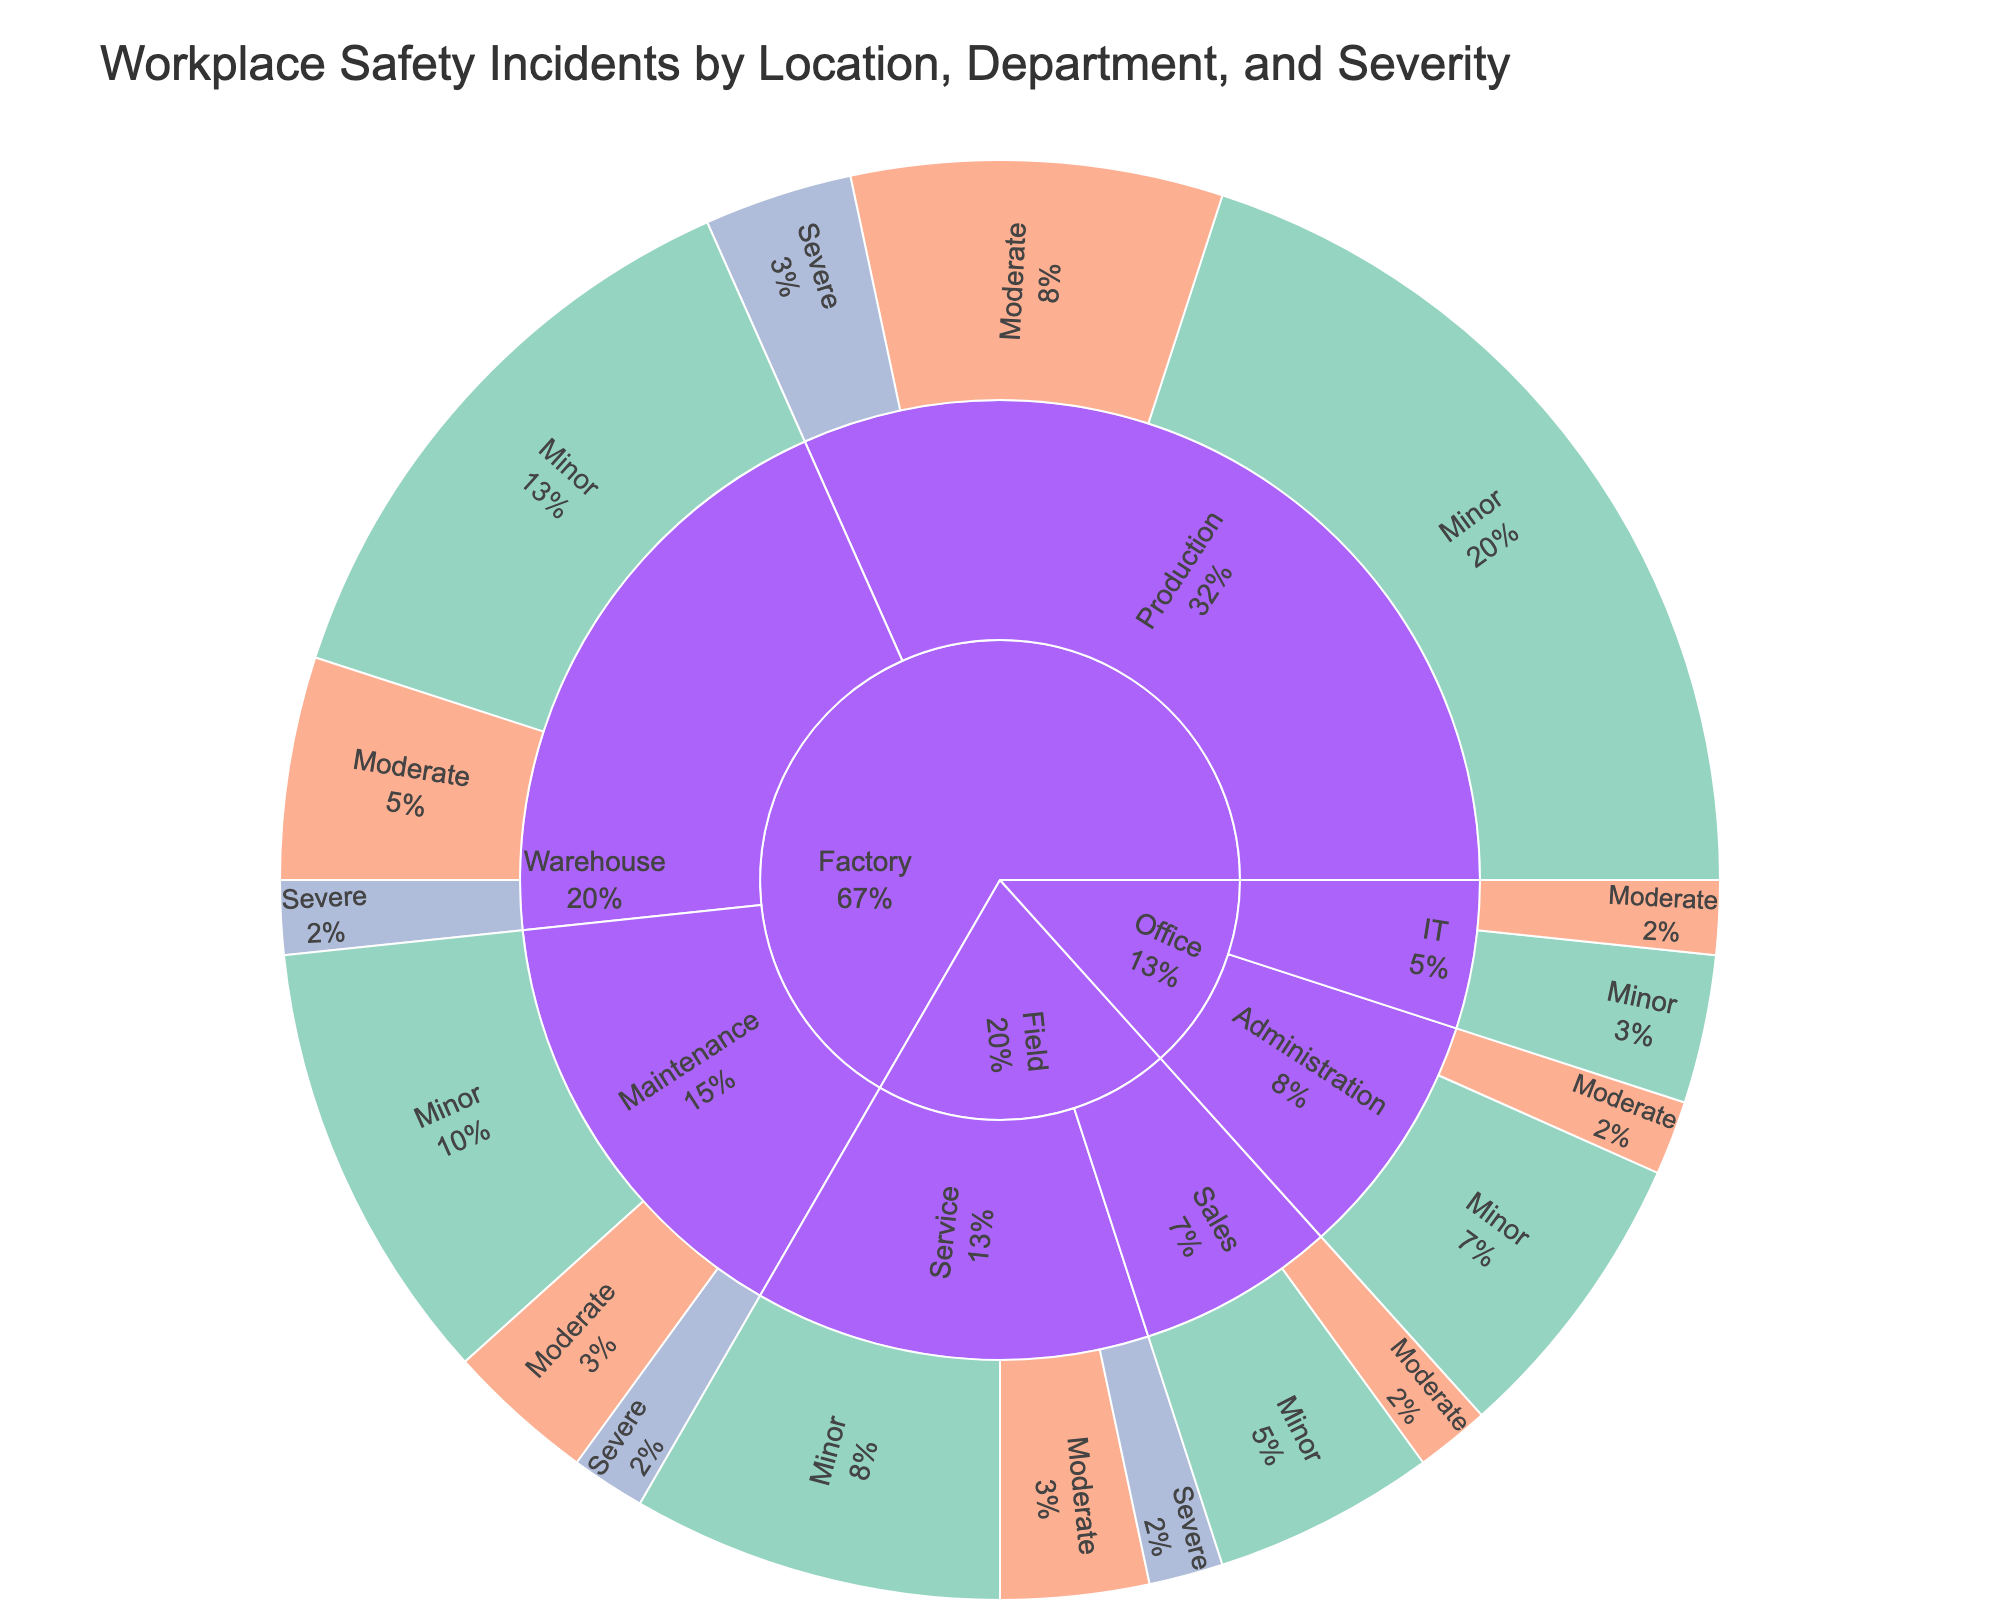What is the title of the Sunburst Plot? The title is usually displayed at the top of the plot and describes the main topic. It explains what the plot represents.
Answer: Workplace Safety Incidents by Location, Department, and Severity What colors represent the severity levels in the plot? The plot uses different colors to distinguish between severity levels: light green for Minor, orange for Moderate, and light blue for Severe. This can be inferred from the color legend or the sunburst plot itself.
Answer: Light green for Minor, orange for Moderate, light blue for Severe Which location has the highest number of incidents? By examining the plot, you can see that the outermost arc representing the "Factory" location is the largest, which indicates Factory has the highest total number of incidents.
Answer: Factory How many incidents are reported in the Office IT department? Locate the Office section, then move to the IT department. The segments representing different severity levels in the IT department sum up to 3 incidents (2 Minor + 1 Moderate).
Answer: 3 Which department in the Factory location has experienced the most Severe incidents? Look within the Factory arc at its departments. Identify and sum the severe segment within each department. The Production department has the largest segment for Severe incidents.
Answer: Production Compare the number of Moderate incidents between the Field and Office locations. Examine and sum the segments for Moderate incidents within each location. The Field location has more Moderate incidents (1 in Sales + 2 in Service = 3) compared to the Office location (1 in Administration + 1 in IT = 2).
Answer: Field What percentage of the total incidents in the Factory location are Severe? Identify the severe incidents in Factory (Production 2 + Warehouse 1 + Maintenance 1 = 4), then calculate their proportion out of the total Factory incidents (12 + 5 + 2 + 8 + 3 + 1 + 6 + 2 + 1 = 40). The percentage is (4/40) * 100 = 10%.
Answer: 10% Are there any departments without Severe incidents? Check all departments in each location for segments that represent Severe incidents. Administration and IT departments in the Office location have no Severe incidents.
Answer: Administration and IT Which department in the Field has the highest total incidents? Look at the Field location and compare the total sizes of the arcs for the Sales and Service departments. The Service department has the highest total incidents (5 Minor + 2 Moderate + 1 Severe = 8).
Answer: Service What is the most common severity type in the Warehouse department of the Factory location? Within the Warehouse department, compare the sizes of the segments representing different severity levels. Minor incidents (8) are the most common.
Answer: Minor 